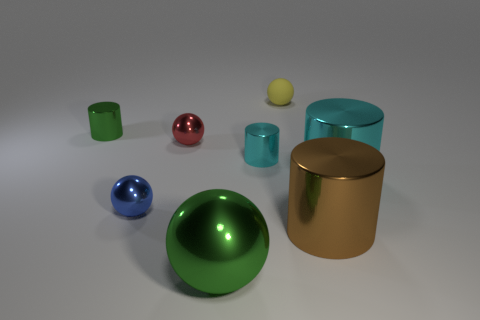Subtract all large brown metallic cylinders. How many cylinders are left? 3 Subtract all gray spheres. Subtract all yellow blocks. How many spheres are left? 4 Add 1 tiny gray shiny cubes. How many tiny gray shiny cubes exist? 1 Subtract 0 cyan spheres. How many objects are left? 8 Subtract all brown metal things. Subtract all big brown cylinders. How many objects are left? 6 Add 2 cylinders. How many cylinders are left? 6 